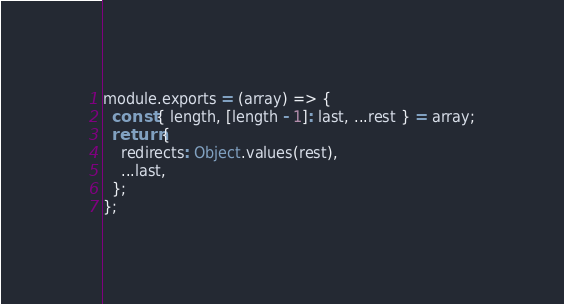<code> <loc_0><loc_0><loc_500><loc_500><_JavaScript_>module.exports = (array) => {
  const { length, [length - 1]: last, ...rest } = array;
  return {
    redirects: Object.values(rest),
    ...last,
  };
};
</code> 